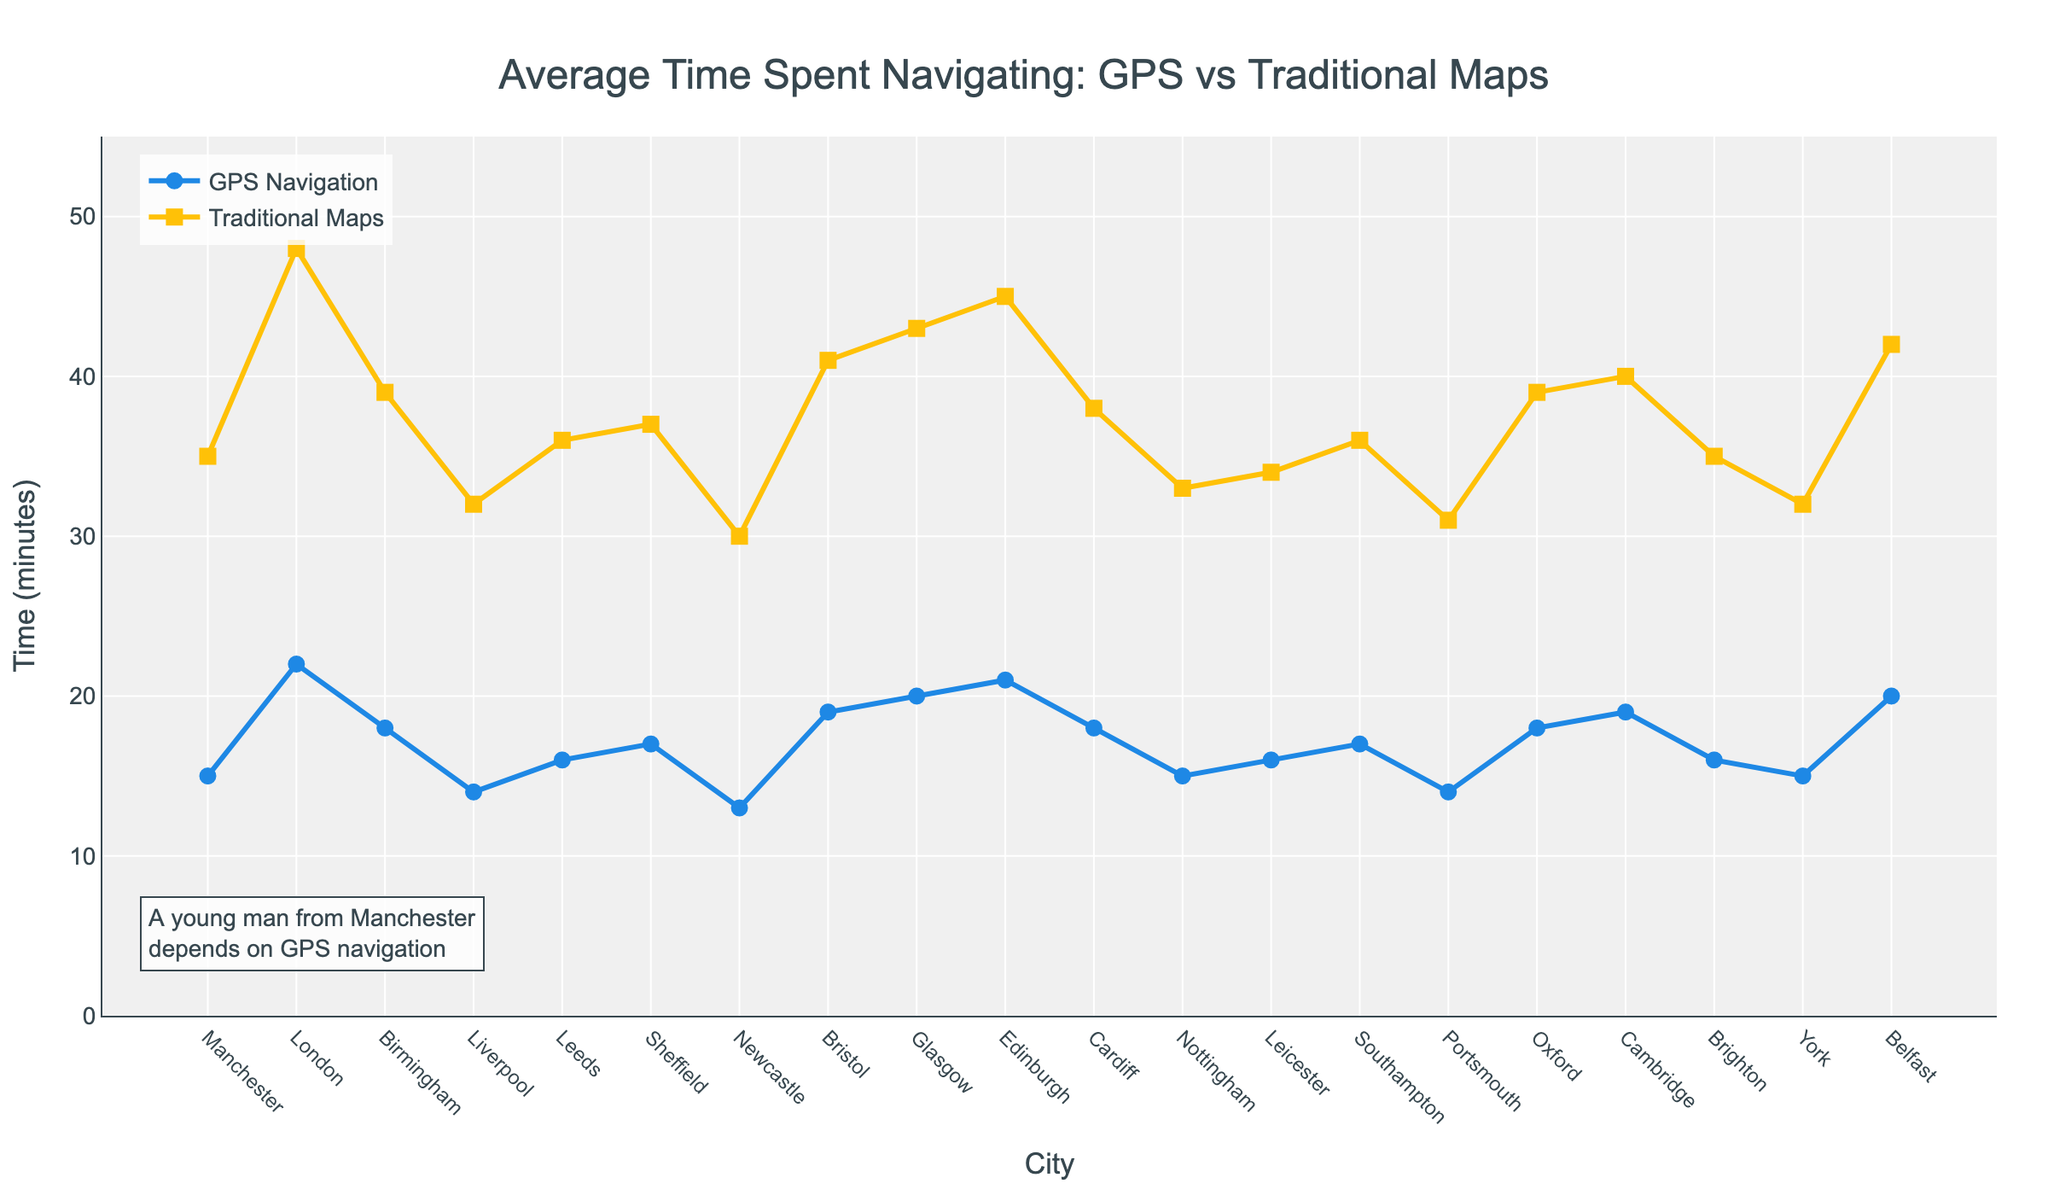What's the average time spent on GPS navigation across all cities? To find the average, sum the GPS navigation times for all cities and divide by the number of cities. The total time is 306 minutes, and there are 20 cities, so the average is 306/20.
Answer: 15.3 minutes Which city spends the least amount of time on GPS navigation, and how much time is it? By observing the line chart for the GPS navigation trace, Newcastle spends the least time.
Answer: Newcastle, 13 minutes How much more time, on average, do people spend using traditional maps compared to GPS navigation across all cities? First, find the average time for both GPS navigation and traditional maps. The total navigation times are 306 minutes (GPS) and 748 minutes (maps). The number of cities is 20. Average times are 306/20 and 748/20. The difference is (748/20) - (306/20).
Answer: 22.1 minutes Which city shows the greatest difference in time spent between GPS navigation and traditional maps? Compare the differences for each city. London has the largest difference: 48-22 = 26 minutes.
Answer: London, 26 minutes In which city is the time spent using traditional maps closest to twice the time spent using GPS navigation? Calculate the ratio of time spent with maps to GPS for each city and find the city where this ratio is closest to 2. Edinburgh has a ratio of 45/21 ≈ 2.14.
Answer: Edinburgh Which two cities have the same time difference between GPS and traditional map navigation? By comparing the differences, Sheffield and Cardiff both have a difference of 20 minutes.
Answer: Sheffield and Cardiff Identify the city with the highest time spent on traditional map navigation and state how many minutes. Looking at the highest point in the traditional maps line, London has the highest time.
Answer: London, 48 minutes Out of Manchester, Liverpool, and Leeds, which city spends the most time using traditional maps? Comparing the traditional map times, Leeds at 36 minutes is higher than Manchester at 35 and Liverpool at 32.
Answer: Leeds, 36 minutes What is the total time difference between GPS navigation and traditional maps across the top 5 cities with the highest traditional map navigation times? London (48-22), Edinburgh (45-21), Glasgow (43-20), Belfast (42-20), Bristol (41-19). The sum is (26 + 24 + 23 + 22 + 22).
Answer: 117 minutes In which city does using GPS navigation save the least amount of time compared to traditional maps? By comparing the time saved (difference), Portsmouth saves the least since traditional maps take 31 minutes and GPS 14 minutes resulting in 17 minutes saved.
Answer: Portsmouth, 17 minutes 